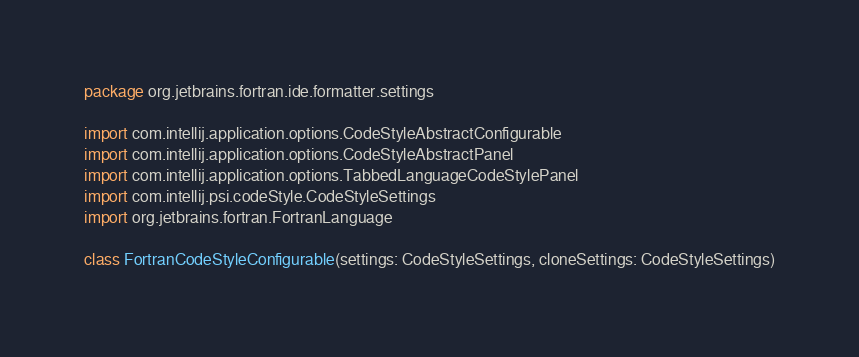Convert code to text. <code><loc_0><loc_0><loc_500><loc_500><_Kotlin_>package org.jetbrains.fortran.ide.formatter.settings

import com.intellij.application.options.CodeStyleAbstractConfigurable
import com.intellij.application.options.CodeStyleAbstractPanel
import com.intellij.application.options.TabbedLanguageCodeStylePanel
import com.intellij.psi.codeStyle.CodeStyleSettings
import org.jetbrains.fortran.FortranLanguage

class FortranCodeStyleConfigurable(settings: CodeStyleSettings, cloneSettings: CodeStyleSettings)</code> 